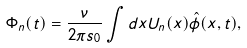Convert formula to latex. <formula><loc_0><loc_0><loc_500><loc_500>\Phi _ { n } ( t ) = \frac { \nu } { 2 \pi s _ { 0 } } \int d x U _ { n } ( x ) \hat { \phi } ( x , t ) ,</formula> 